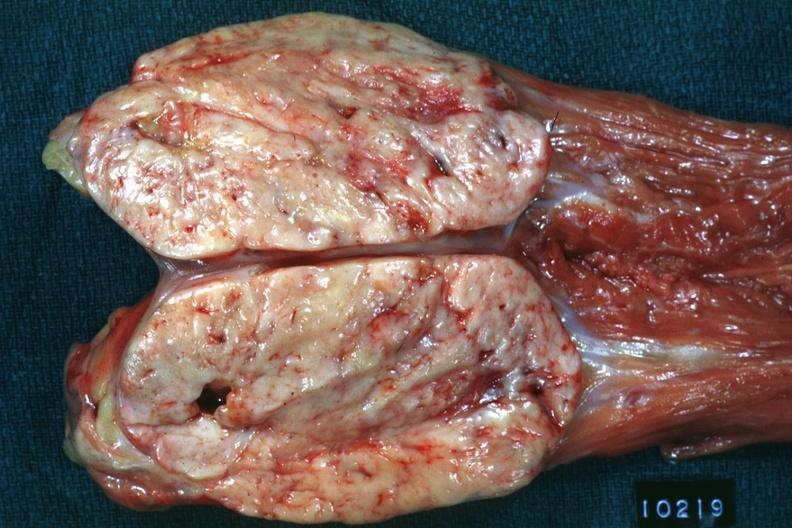s abdomen present?
Answer the question using a single word or phrase. Yes 